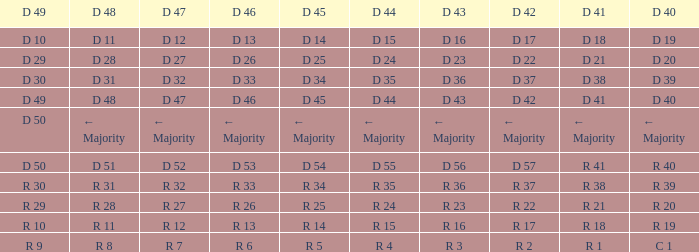I want the D 40 with D 44 of d 15 D 19. 